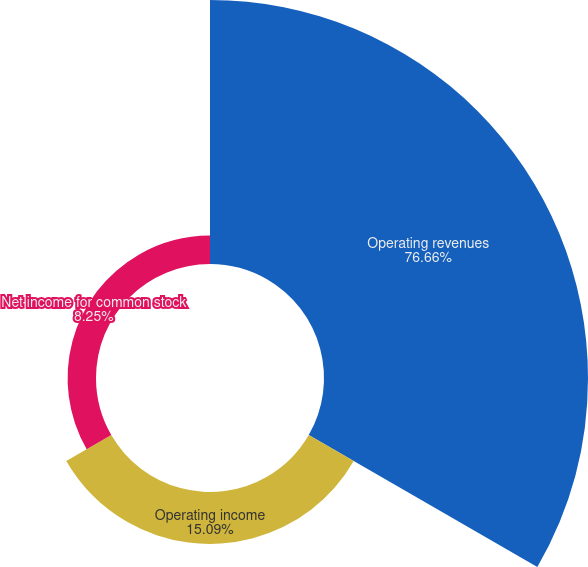Convert chart. <chart><loc_0><loc_0><loc_500><loc_500><pie_chart><fcel>Operating revenues<fcel>Operating income<fcel>Net income for common stock<nl><fcel>76.66%<fcel>15.09%<fcel>8.25%<nl></chart> 